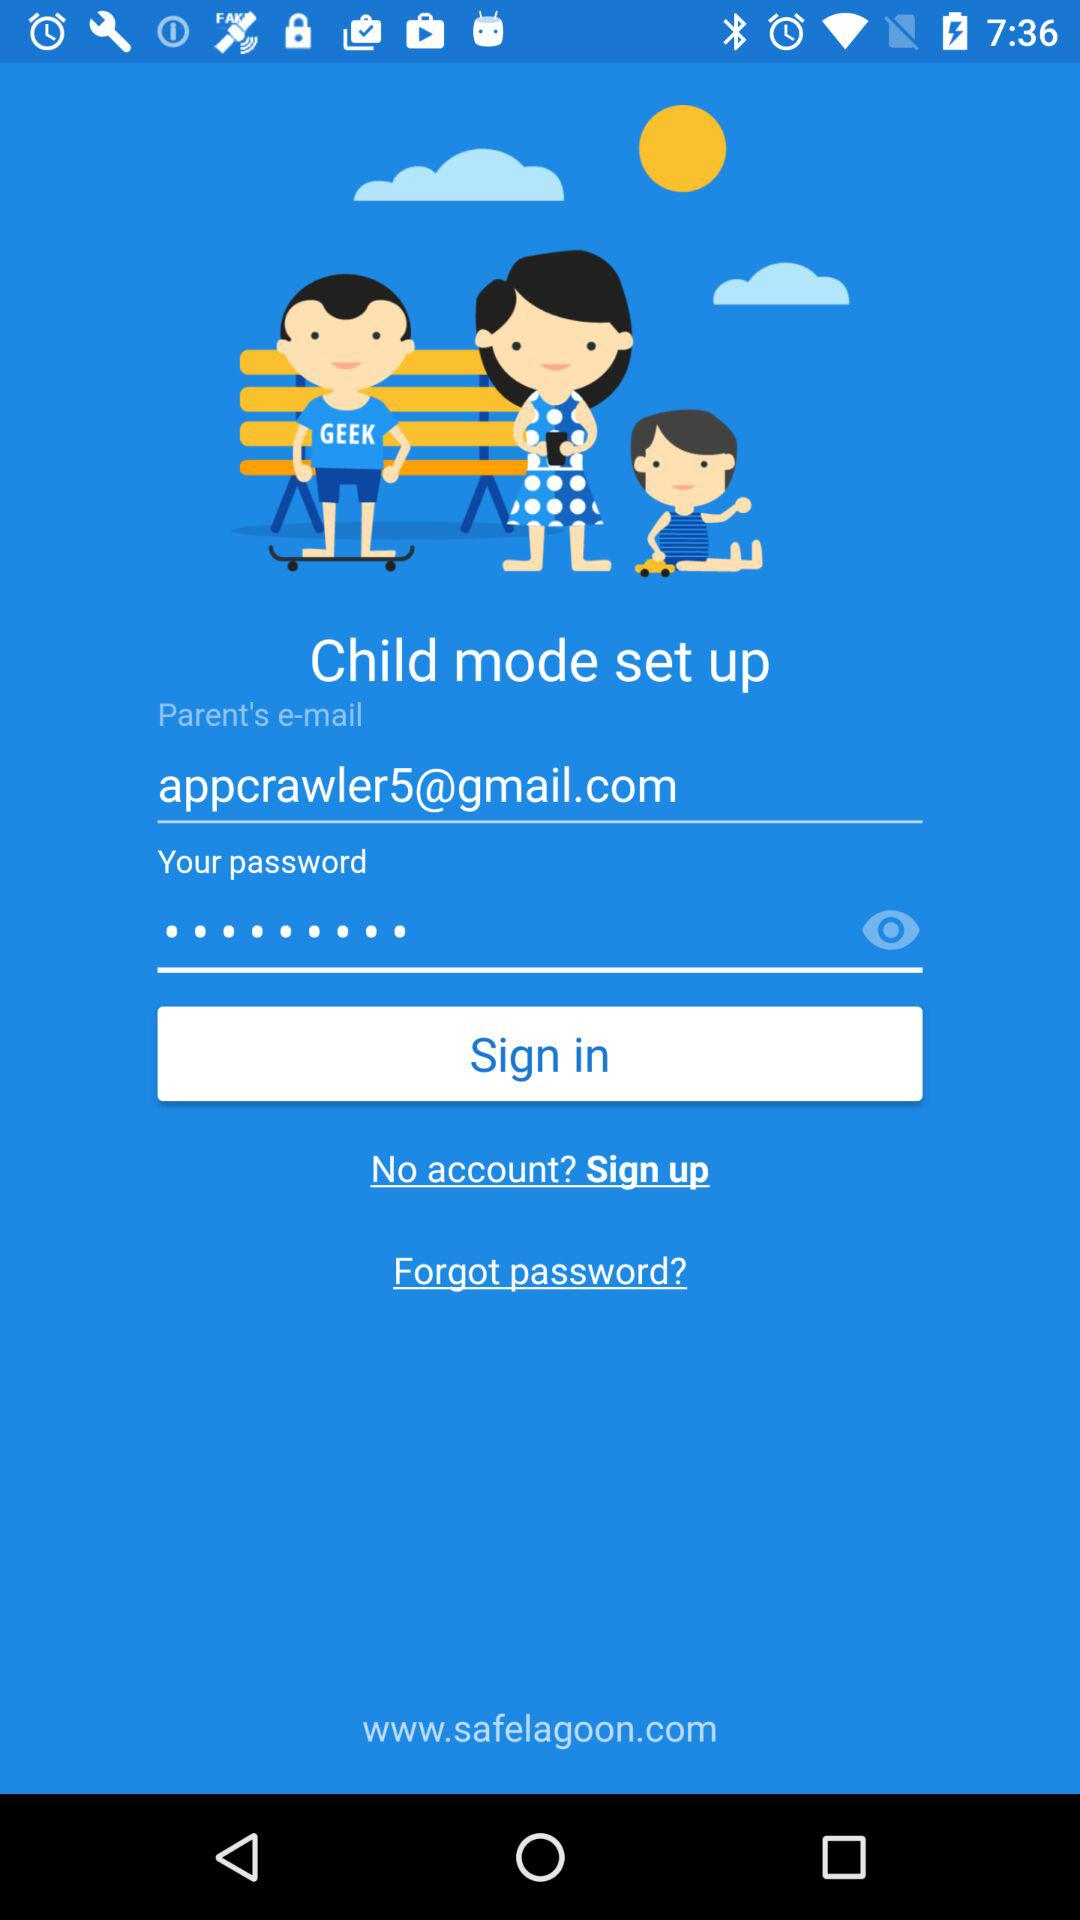What is the email address? The email address is appcrawler5@gmail.com. 